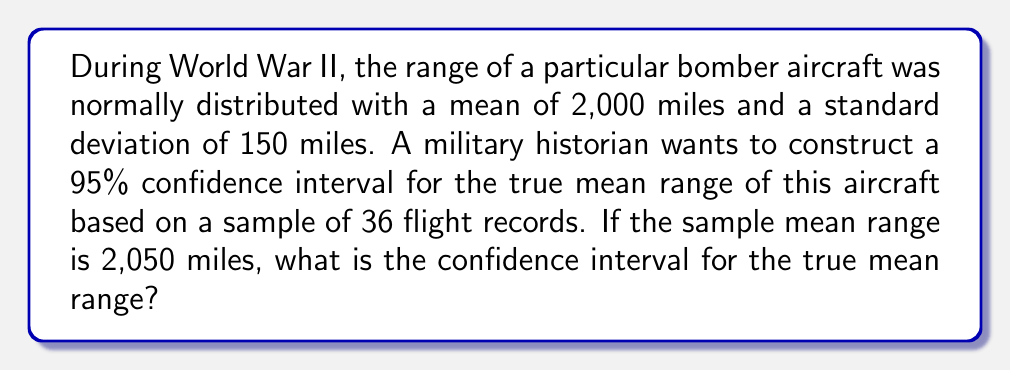Can you answer this question? Let's approach this step-by-step:

1) We're given:
   - Confidence level = 95%
   - Sample size (n) = 36
   - Sample mean ($\bar{x}$) = 2,050 miles
   - Population standard deviation ($\sigma$) = 150 miles

2) For a 95% confidence interval, we use a z-score of 1.96 (from the standard normal distribution table).

3) The formula for the confidence interval is:

   $$\bar{x} \pm z \frac{\sigma}{\sqrt{n}}$$

4) Substituting our values:

   $$2050 \pm 1.96 \frac{150}{\sqrt{36}}$$

5) Simplify:
   $$2050 \pm 1.96 \frac{150}{6}$$
   $$2050 \pm 1.96 (25)$$
   $$2050 \pm 49$$

6) Calculate the interval:
   Lower bound: 2050 - 49 = 2001
   Upper bound: 2050 + 49 = 2099

Therefore, we can be 95% confident that the true mean range of the bomber aircraft is between 2,001 and 2,099 miles.
Answer: (2001, 2099) miles 